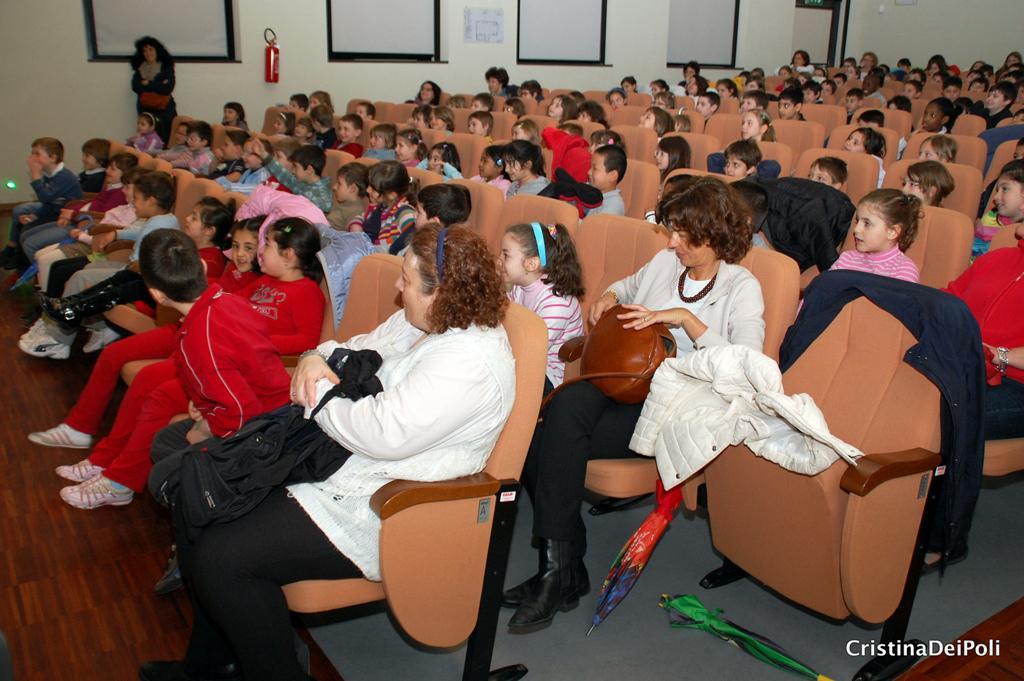Can you describe this image briefly? In this image I can see number of children and few women are sitting on chairs. I can also see few jackets, few umbrellas, few bags and here I can see watermark. In background I can see a red colour thing on wall. 